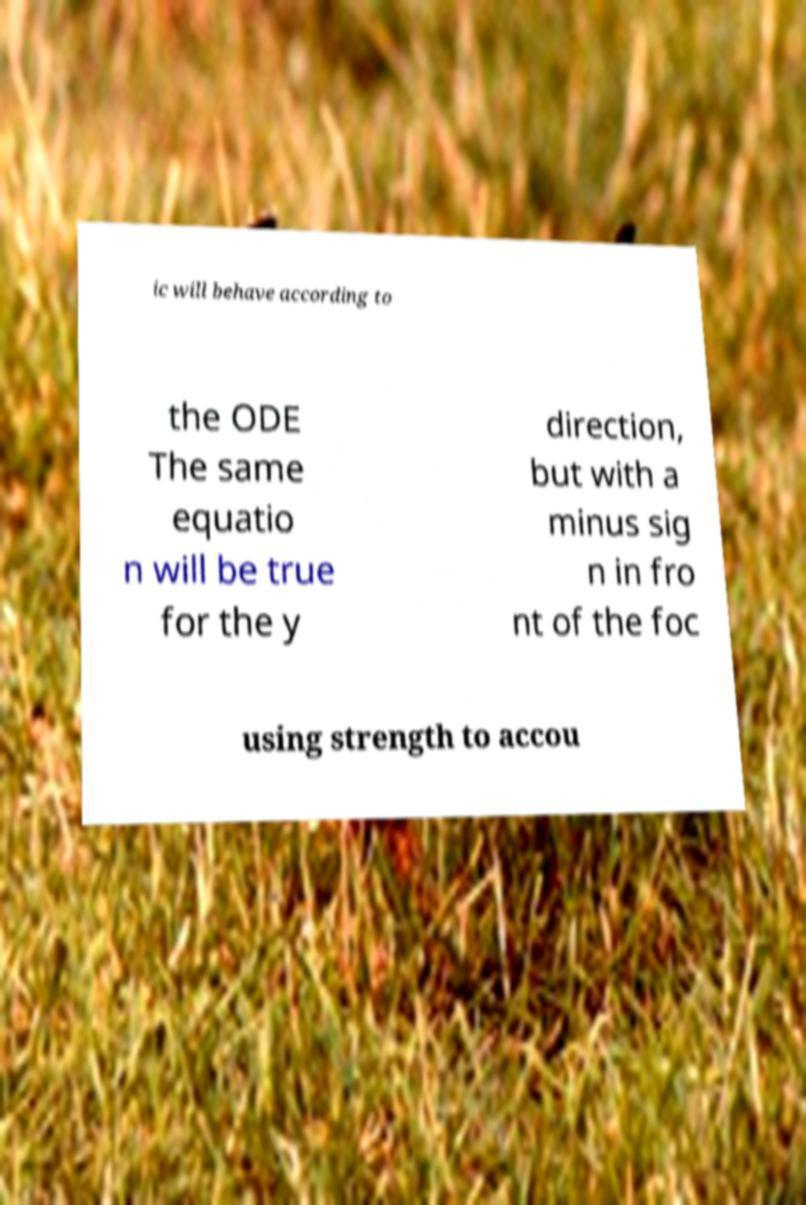For documentation purposes, I need the text within this image transcribed. Could you provide that? ic will behave according to the ODE The same equatio n will be true for the y direction, but with a minus sig n in fro nt of the foc using strength to accou 